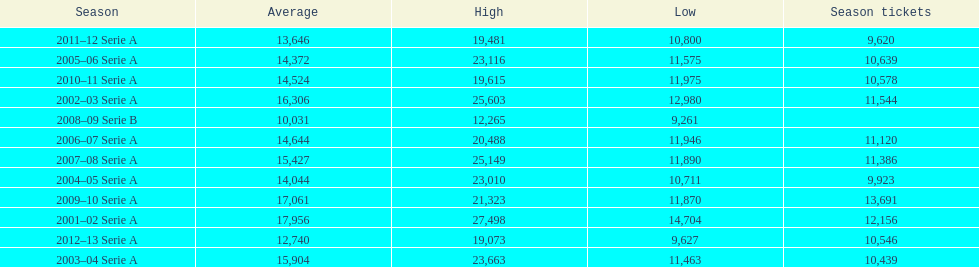How many seasons had average attendance of at least 15,000 at the stadio ennio tardini? 5. 